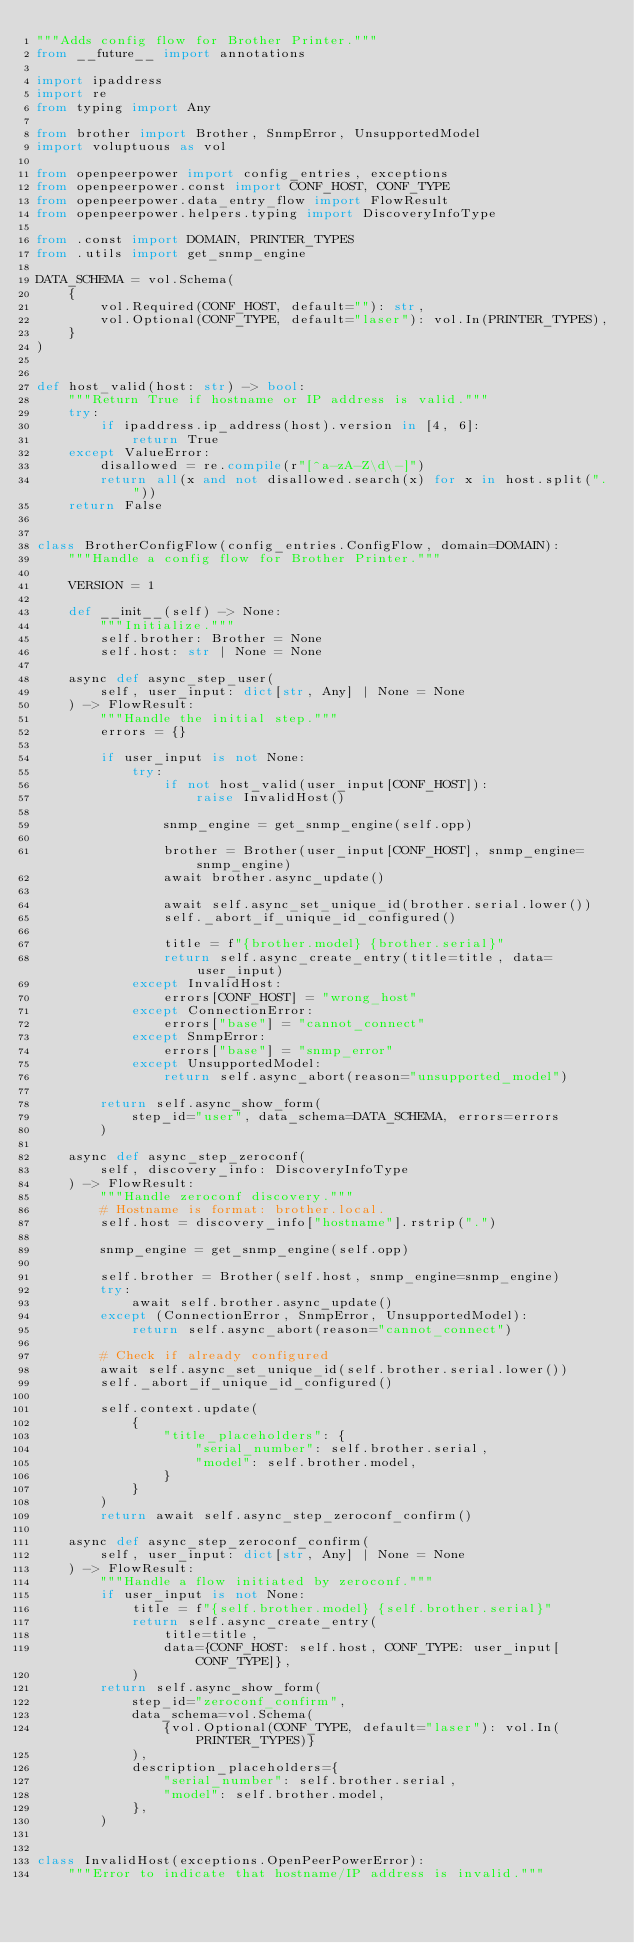Convert code to text. <code><loc_0><loc_0><loc_500><loc_500><_Python_>"""Adds config flow for Brother Printer."""
from __future__ import annotations

import ipaddress
import re
from typing import Any

from brother import Brother, SnmpError, UnsupportedModel
import voluptuous as vol

from openpeerpower import config_entries, exceptions
from openpeerpower.const import CONF_HOST, CONF_TYPE
from openpeerpower.data_entry_flow import FlowResult
from openpeerpower.helpers.typing import DiscoveryInfoType

from .const import DOMAIN, PRINTER_TYPES
from .utils import get_snmp_engine

DATA_SCHEMA = vol.Schema(
    {
        vol.Required(CONF_HOST, default=""): str,
        vol.Optional(CONF_TYPE, default="laser"): vol.In(PRINTER_TYPES),
    }
)


def host_valid(host: str) -> bool:
    """Return True if hostname or IP address is valid."""
    try:
        if ipaddress.ip_address(host).version in [4, 6]:
            return True
    except ValueError:
        disallowed = re.compile(r"[^a-zA-Z\d\-]")
        return all(x and not disallowed.search(x) for x in host.split("."))
    return False


class BrotherConfigFlow(config_entries.ConfigFlow, domain=DOMAIN):
    """Handle a config flow for Brother Printer."""

    VERSION = 1

    def __init__(self) -> None:
        """Initialize."""
        self.brother: Brother = None
        self.host: str | None = None

    async def async_step_user(
        self, user_input: dict[str, Any] | None = None
    ) -> FlowResult:
        """Handle the initial step."""
        errors = {}

        if user_input is not None:
            try:
                if not host_valid(user_input[CONF_HOST]):
                    raise InvalidHost()

                snmp_engine = get_snmp_engine(self.opp)

                brother = Brother(user_input[CONF_HOST], snmp_engine=snmp_engine)
                await brother.async_update()

                await self.async_set_unique_id(brother.serial.lower())
                self._abort_if_unique_id_configured()

                title = f"{brother.model} {brother.serial}"
                return self.async_create_entry(title=title, data=user_input)
            except InvalidHost:
                errors[CONF_HOST] = "wrong_host"
            except ConnectionError:
                errors["base"] = "cannot_connect"
            except SnmpError:
                errors["base"] = "snmp_error"
            except UnsupportedModel:
                return self.async_abort(reason="unsupported_model")

        return self.async_show_form(
            step_id="user", data_schema=DATA_SCHEMA, errors=errors
        )

    async def async_step_zeroconf(
        self, discovery_info: DiscoveryInfoType
    ) -> FlowResult:
        """Handle zeroconf discovery."""
        # Hostname is format: brother.local.
        self.host = discovery_info["hostname"].rstrip(".")

        snmp_engine = get_snmp_engine(self.opp)

        self.brother = Brother(self.host, snmp_engine=snmp_engine)
        try:
            await self.brother.async_update()
        except (ConnectionError, SnmpError, UnsupportedModel):
            return self.async_abort(reason="cannot_connect")

        # Check if already configured
        await self.async_set_unique_id(self.brother.serial.lower())
        self._abort_if_unique_id_configured()

        self.context.update(
            {
                "title_placeholders": {
                    "serial_number": self.brother.serial,
                    "model": self.brother.model,
                }
            }
        )
        return await self.async_step_zeroconf_confirm()

    async def async_step_zeroconf_confirm(
        self, user_input: dict[str, Any] | None = None
    ) -> FlowResult:
        """Handle a flow initiated by zeroconf."""
        if user_input is not None:
            title = f"{self.brother.model} {self.brother.serial}"
            return self.async_create_entry(
                title=title,
                data={CONF_HOST: self.host, CONF_TYPE: user_input[CONF_TYPE]},
            )
        return self.async_show_form(
            step_id="zeroconf_confirm",
            data_schema=vol.Schema(
                {vol.Optional(CONF_TYPE, default="laser"): vol.In(PRINTER_TYPES)}
            ),
            description_placeholders={
                "serial_number": self.brother.serial,
                "model": self.brother.model,
            },
        )


class InvalidHost(exceptions.OpenPeerPowerError):
    """Error to indicate that hostname/IP address is invalid."""
</code> 